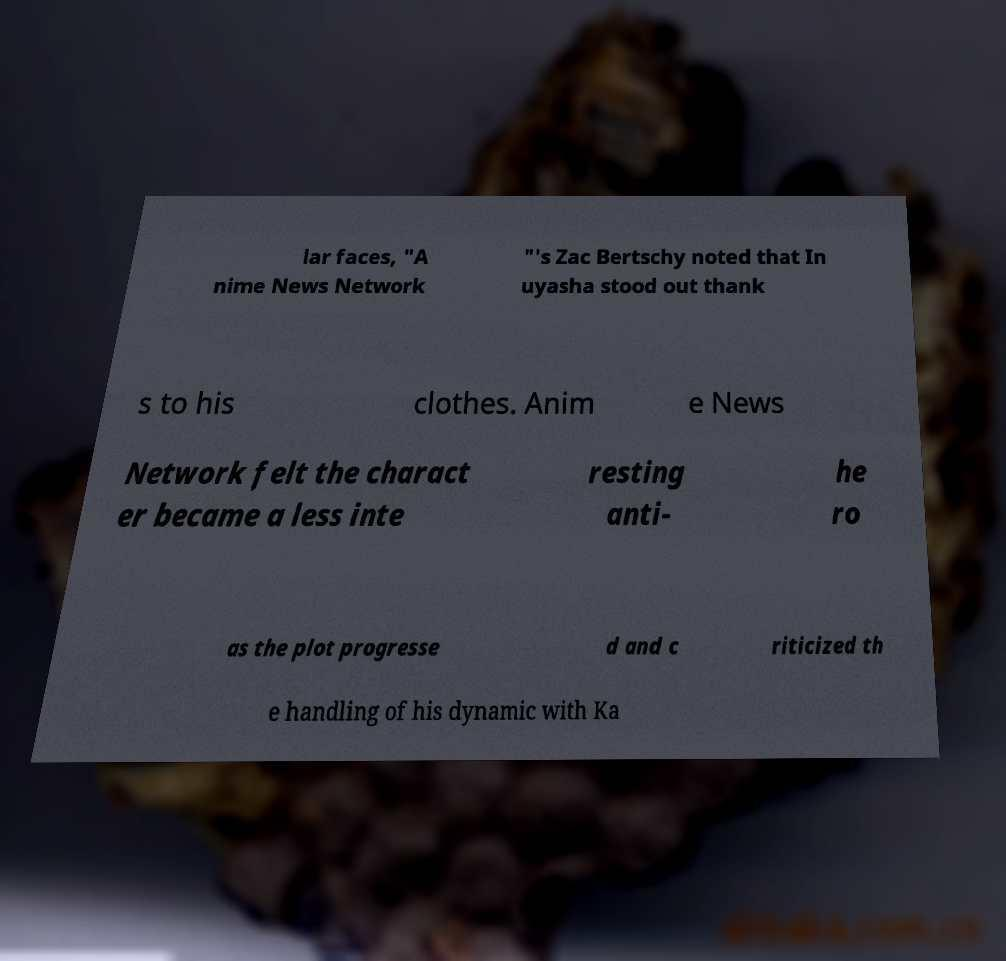For documentation purposes, I need the text within this image transcribed. Could you provide that? lar faces, "A nime News Network "'s Zac Bertschy noted that In uyasha stood out thank s to his clothes. Anim e News Network felt the charact er became a less inte resting anti- he ro as the plot progresse d and c riticized th e handling of his dynamic with Ka 